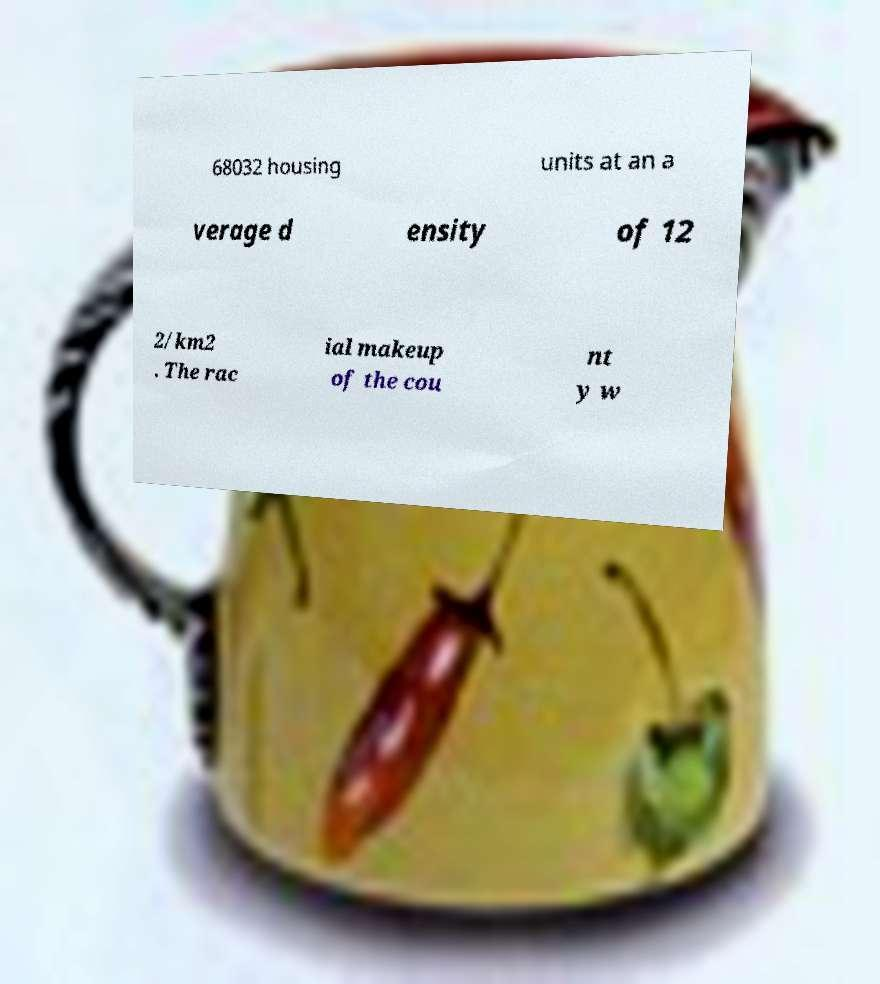I need the written content from this picture converted into text. Can you do that? 68032 housing units at an a verage d ensity of 12 2/km2 . The rac ial makeup of the cou nt y w 